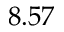Convert formula to latex. <formula><loc_0><loc_0><loc_500><loc_500>8 . 5 7</formula> 